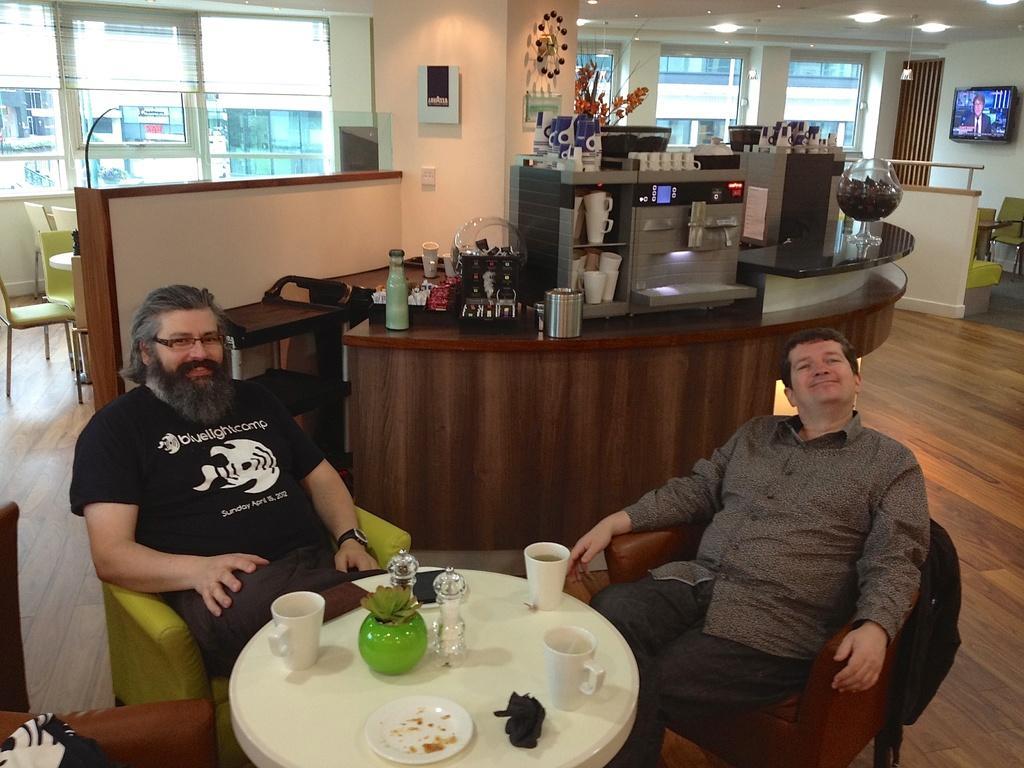Please provide a concise description of this image. In this picture there are two men sitting on a chair. There is a cup , plate, cloth , bowl, glass on the table. There are few things at the background. There is a light and TV. There is a building at the background. 